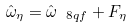<formula> <loc_0><loc_0><loc_500><loc_500>\hat { \omega } _ { \eta } = \hat { \omega } _ { \ 8 { q f } } + F _ { \eta }</formula> 